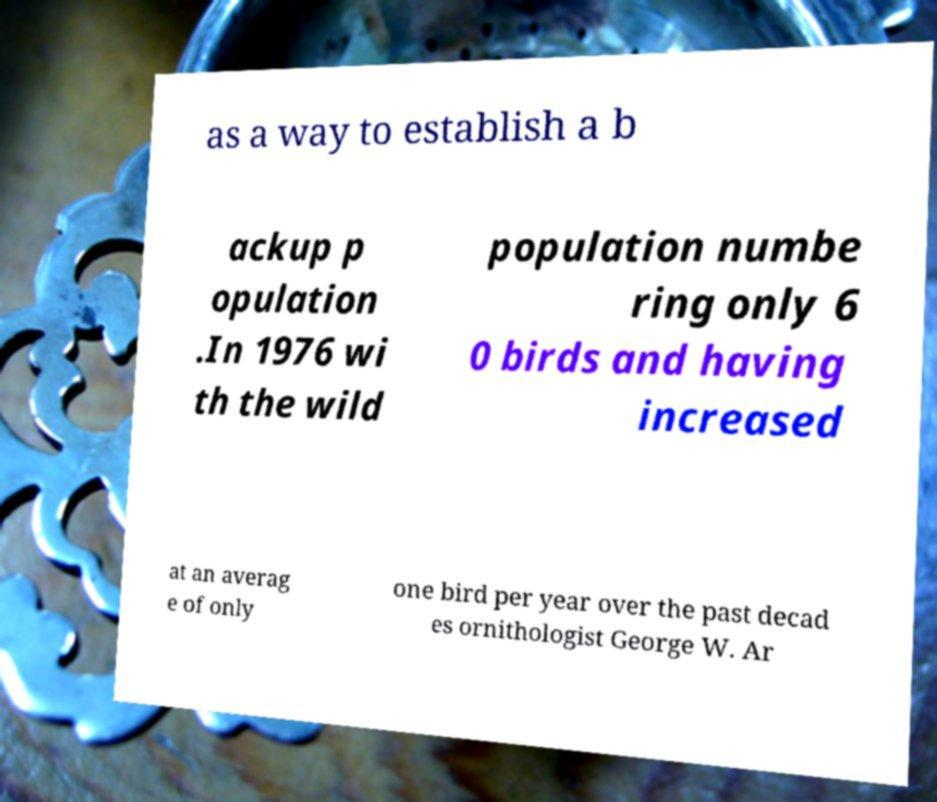For documentation purposes, I need the text within this image transcribed. Could you provide that? as a way to establish a b ackup p opulation .In 1976 wi th the wild population numbe ring only 6 0 birds and having increased at an averag e of only one bird per year over the past decad es ornithologist George W. Ar 